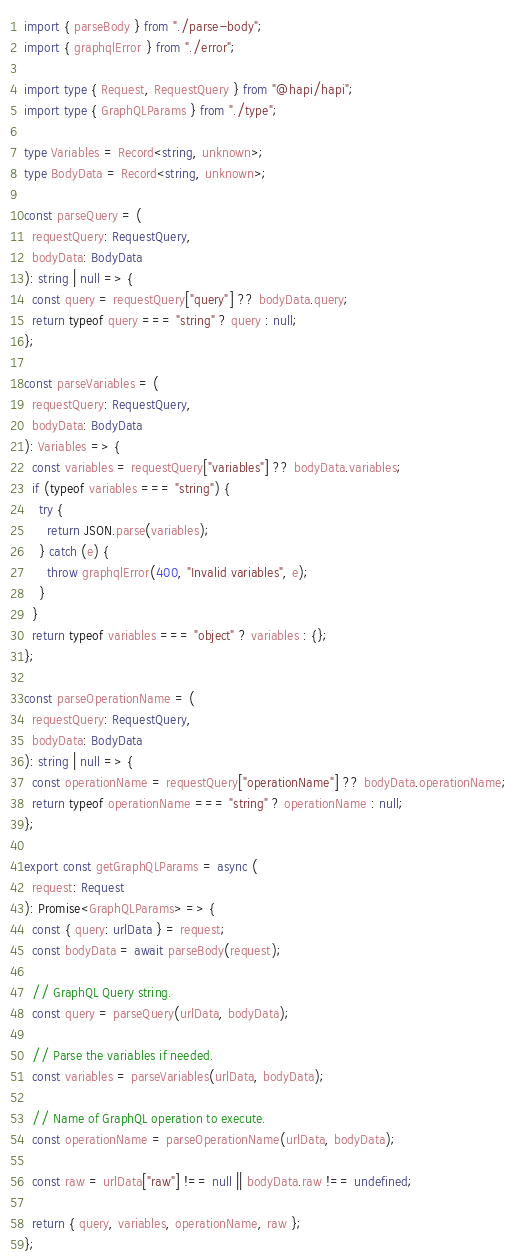<code> <loc_0><loc_0><loc_500><loc_500><_TypeScript_>import { parseBody } from "./parse-body";
import { graphqlError } from "./error";

import type { Request, RequestQuery } from "@hapi/hapi";
import type { GraphQLParams } from "./type";

type Variables = Record<string, unknown>;
type BodyData = Record<string, unknown>;

const parseQuery = (
  requestQuery: RequestQuery,
  bodyData: BodyData
): string | null => {
  const query = requestQuery["query"] ?? bodyData.query;
  return typeof query === "string" ? query : null;
};

const parseVariables = (
  requestQuery: RequestQuery,
  bodyData: BodyData
): Variables => {
  const variables = requestQuery["variables"] ?? bodyData.variables;
  if (typeof variables === "string") {
    try {
      return JSON.parse(variables);
    } catch (e) {
      throw graphqlError(400, "Invalid variables", e);
    }
  }
  return typeof variables === "object" ? variables : {};
};

const parseOperationName = (
  requestQuery: RequestQuery,
  bodyData: BodyData
): string | null => {
  const operationName = requestQuery["operationName"] ?? bodyData.operationName;
  return typeof operationName === "string" ? operationName : null;
};

export const getGraphQLParams = async (
  request: Request
): Promise<GraphQLParams> => {
  const { query: urlData } = request;
  const bodyData = await parseBody(request);

  // GraphQL Query string.
  const query = parseQuery(urlData, bodyData);

  // Parse the variables if needed.
  const variables = parseVariables(urlData, bodyData);

  // Name of GraphQL operation to execute.
  const operationName = parseOperationName(urlData, bodyData);

  const raw = urlData["raw"] !== null || bodyData.raw !== undefined;

  return { query, variables, operationName, raw };
};
</code> 